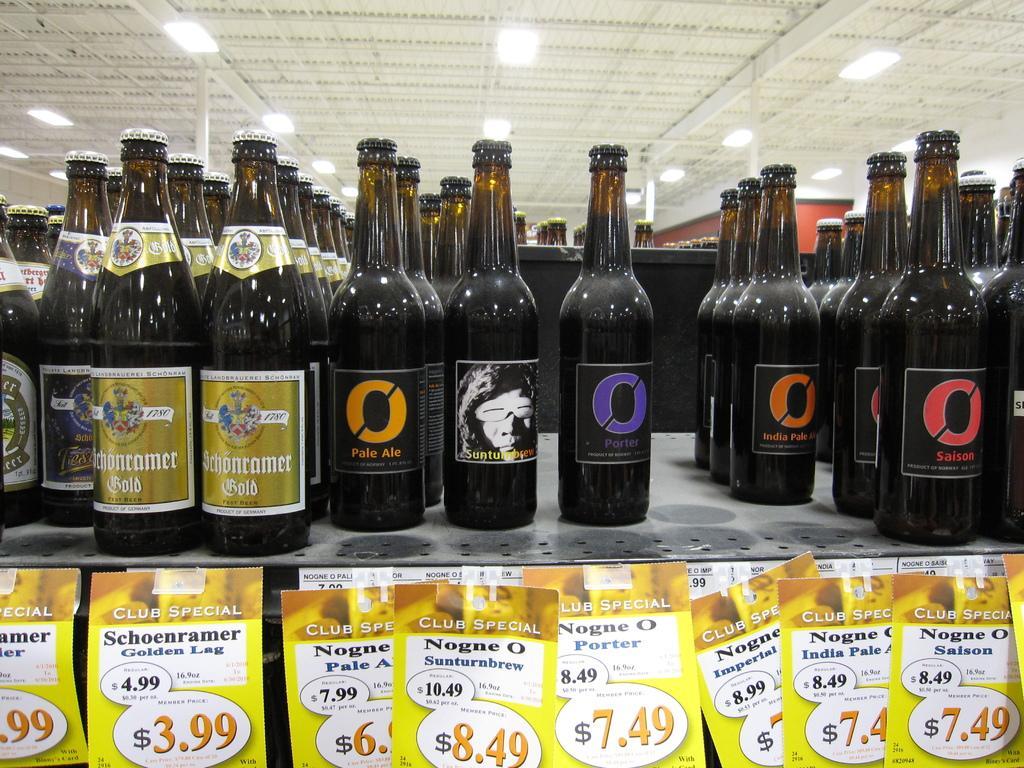In one or two sentences, can you explain what this image depicts? In this image I can see number of bottles and also number of papers. 